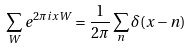Convert formula to latex. <formula><loc_0><loc_0><loc_500><loc_500>\sum _ { W } e ^ { 2 \pi i x W } = \frac { 1 } { 2 \pi } \sum _ { n } \delta ( x - n )</formula> 